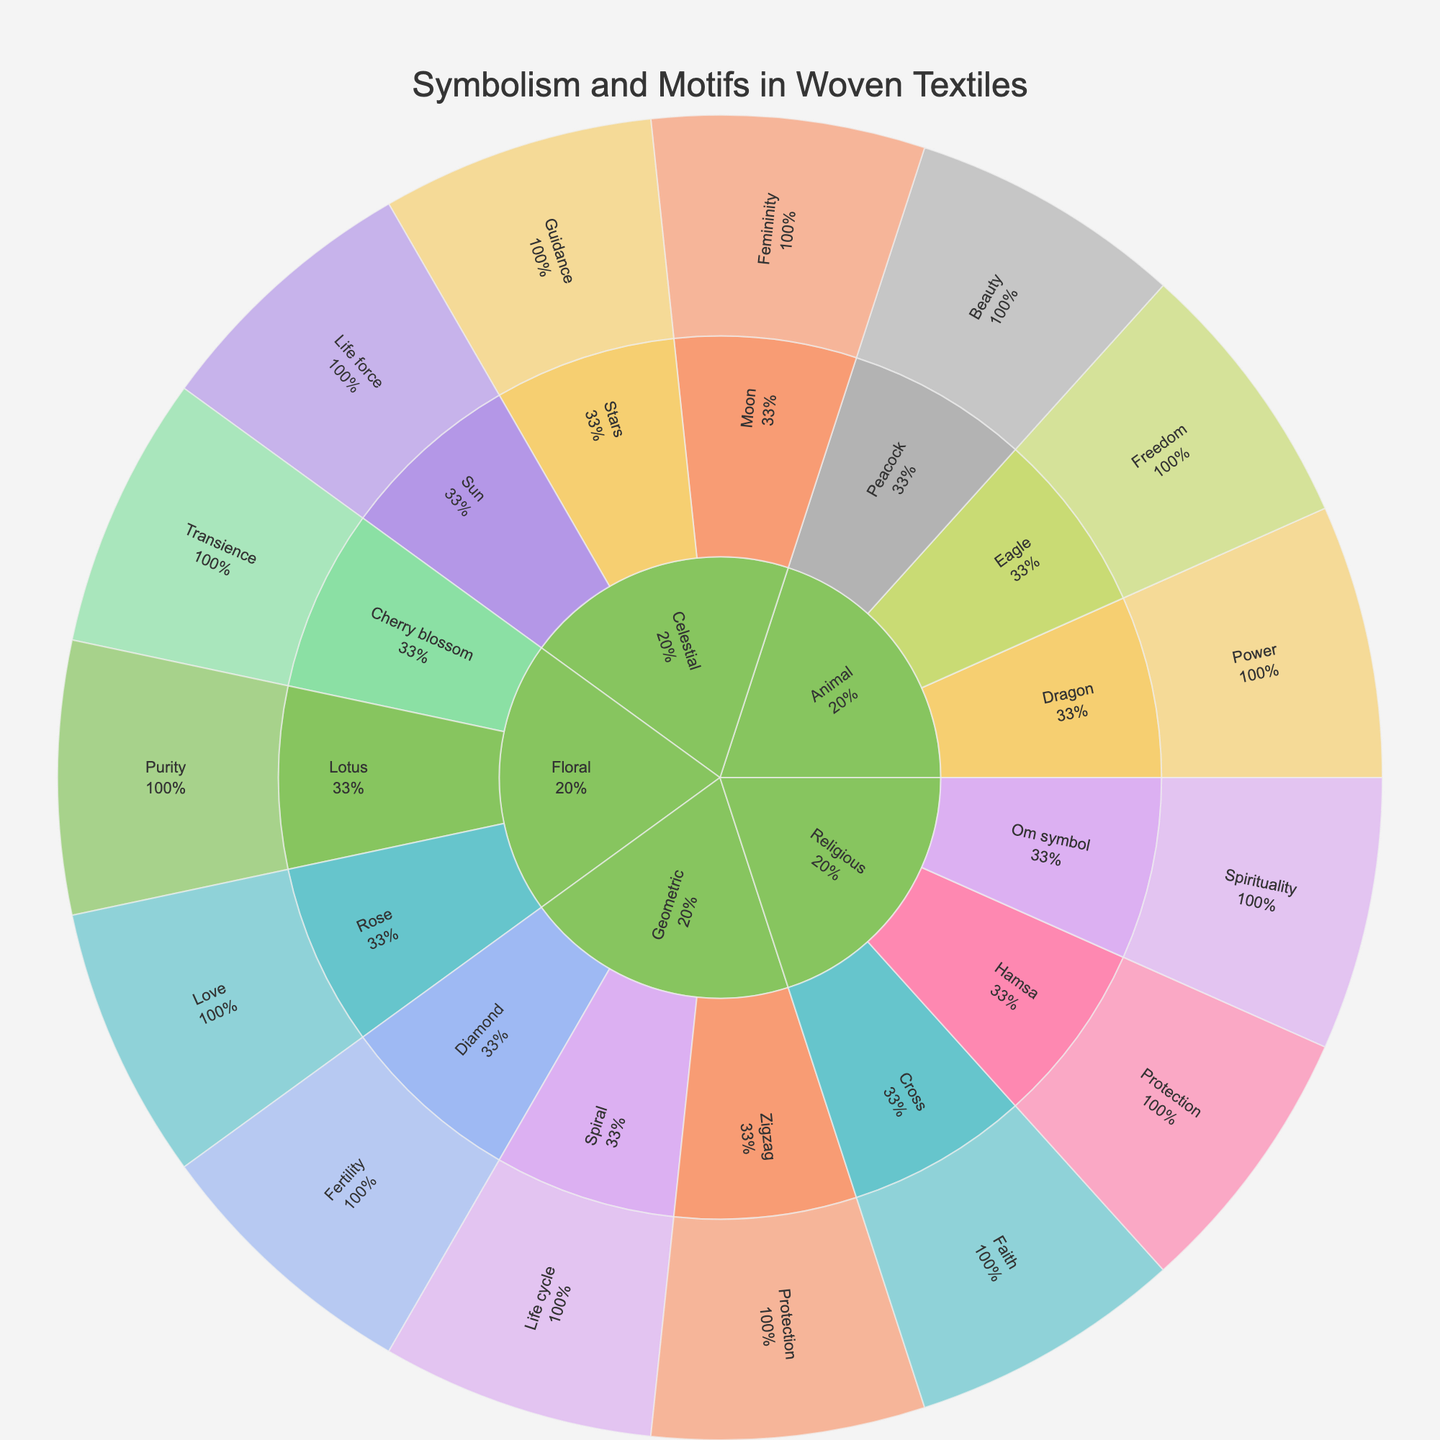what is the title of the figure? The title is usually displayed prominently at the top of the figure. In this case, the title is clearly stated in the code as part of the figure layout.
Answer: Symbolism and Motifs in Woven Textiles How many main categories are there in the plot? By looking at the first level of the Sunburst Plot, which shows the main divisions of the data, we can count the different categories present.
Answer: 5 Which theme under the 'Floral' category has its origin in Japan? Follow the 'Floral' category path in the figure to find the subcategories/themes, then look at the theme that originates from Japan.
Answer: Cherry blossom What is the cultural significance of the 'Om symbol' motif? By locating the 'Om symbol' under the 'Religious' category in the Sunburst Plot, we can hover over it or read the associated information to find the cultural significance.
Answer: Buddhist philosophy Which category has the most subcategories and what are they? By examining the Sunburst Plot, we look for the category that branches out into the most subcategories. Then, list the subcategories found under it.
Answer: Geometric; Zigzag, Diamond, Spiral Which categories have motifs that indicate a theme related to 'Protection'? Follow the level of themes in the Sunburst Plot and see which categories have themes labeled under 'Protection'.
Answer: Geometric, Religious Compare the themes of 'Peacock' and 'Dragon'. Which culture does each originate from, and what is their significance? Locate 'Peacock' and 'Dragon' themes within their respective categories and subcategories in the Sunburst Plot, then check their origins and significances.
Answer: Peacock: Ottoman, Divine protection; Dragon: Chinese, Imperial authority In the 'Celestial' category, which themes originate from Polynesian culture, and what do they symbolize? Navigate the 'Celestial' category in the Sunburst Plot, identify the themes related to Polynesian culture, and check their symbolism.
Answer: Stars, Navigation and destiny 